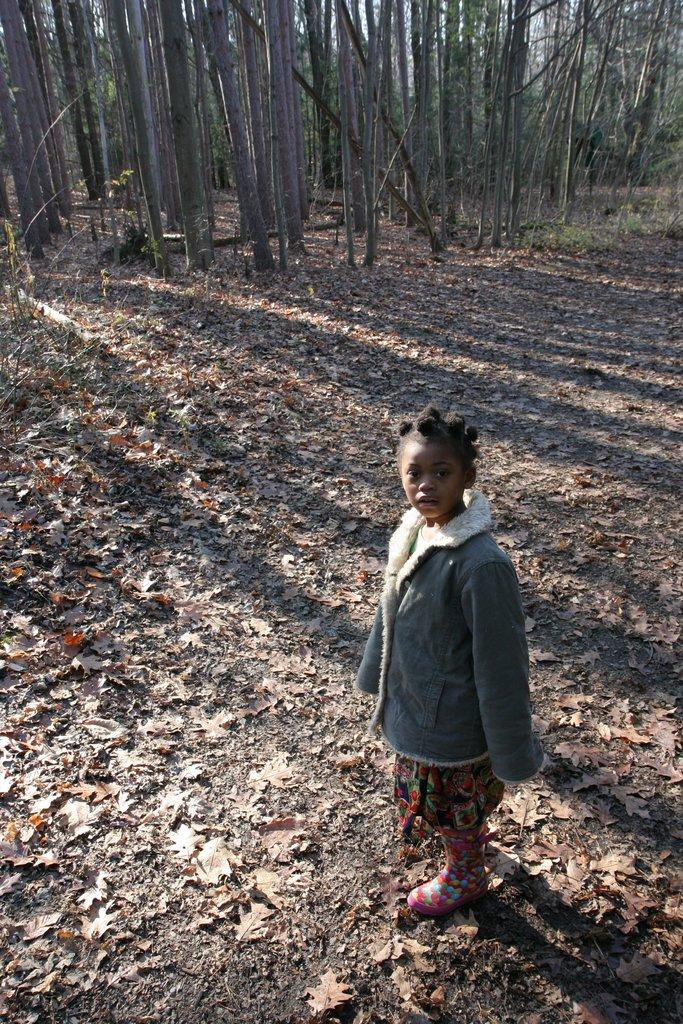Who is the main subject in the picture? There is a girl in the picture. What is the girl wearing? The girl is wearing a grey jacket. Where is the girl positioned in relation to the image? The girl is standing in front of the image. What is the girl doing in the picture? The girl is looking at the camera. What type of natural elements can be seen at the bottom of the image? Dry leaves and twigs are visible at the bottom of the image. What can be seen in the background of the image? There are trees in the background of the image. What invention is the girl holding in her hand in the image? There is no invention visible in the girl's hand in the image. Is there a church visible in the background of the image? No, there is no church present in the image; only trees can be seen in the background. 